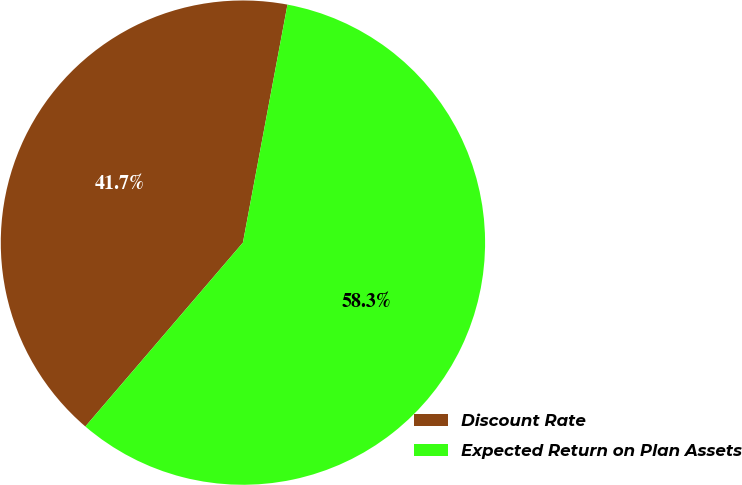Convert chart. <chart><loc_0><loc_0><loc_500><loc_500><pie_chart><fcel>Discount Rate<fcel>Expected Return on Plan Assets<nl><fcel>41.67%<fcel>58.33%<nl></chart> 